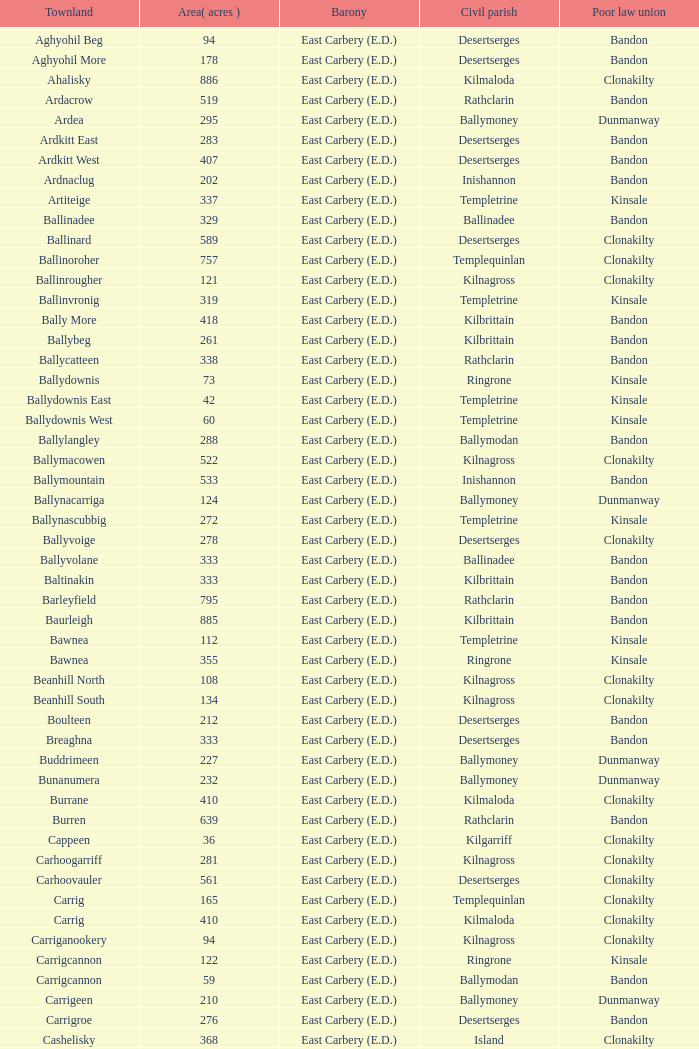What is the poor law union of the Ardacrow townland? Bandon. 